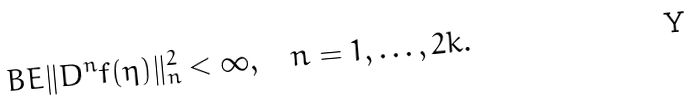<formula> <loc_0><loc_0><loc_500><loc_500>\ B E \| D ^ { n } f ( \eta ) \| _ { n } ^ { 2 } < \infty , \quad n = 1 , \dots , 2 k .</formula> 